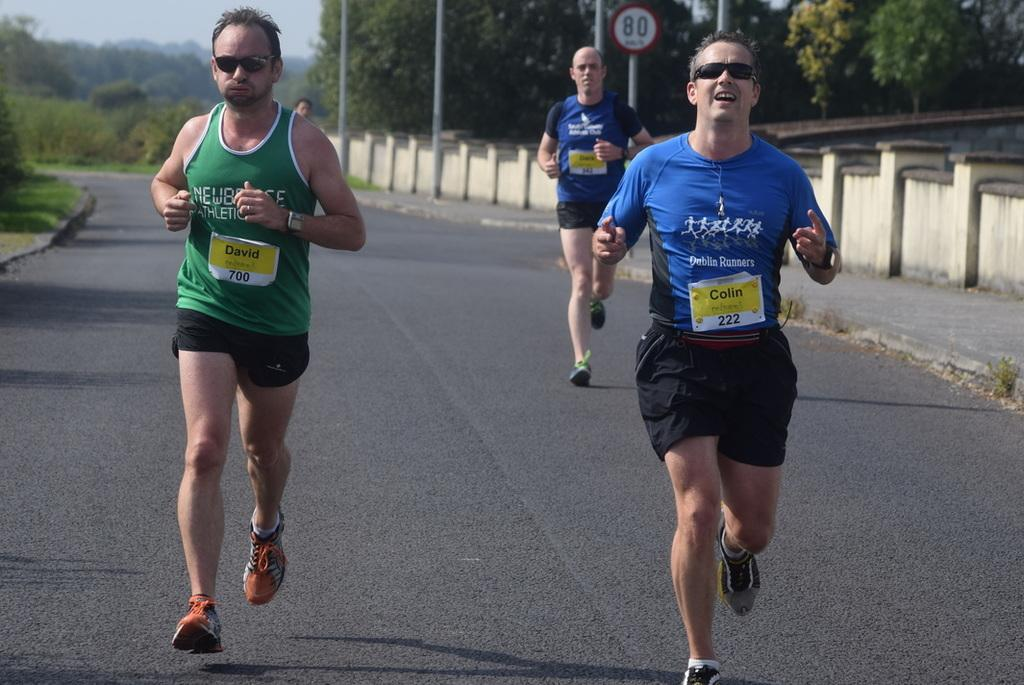What are the people in the image doing? The people in the image are running on the road. What can be seen in the background of the image? In the background, there are poles, trees, a board, a fence, and a shed. Can you describe the poles in the background? The poles in the background are likely utility poles, as they are common along roadsides. How many legs can be seen on the back of the bushes in the image? There are no bushes present in the image, and therefore no legs can be seen on their backs. 